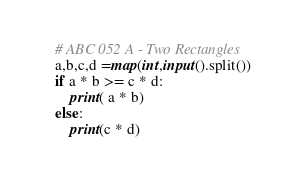<code> <loc_0><loc_0><loc_500><loc_500><_Python_># ABC 052 A - Two Rectangles
a,b,c,d =map(int,input().split())
if a * b >= c * d:
    print( a * b)
else:
    print(c * d)</code> 